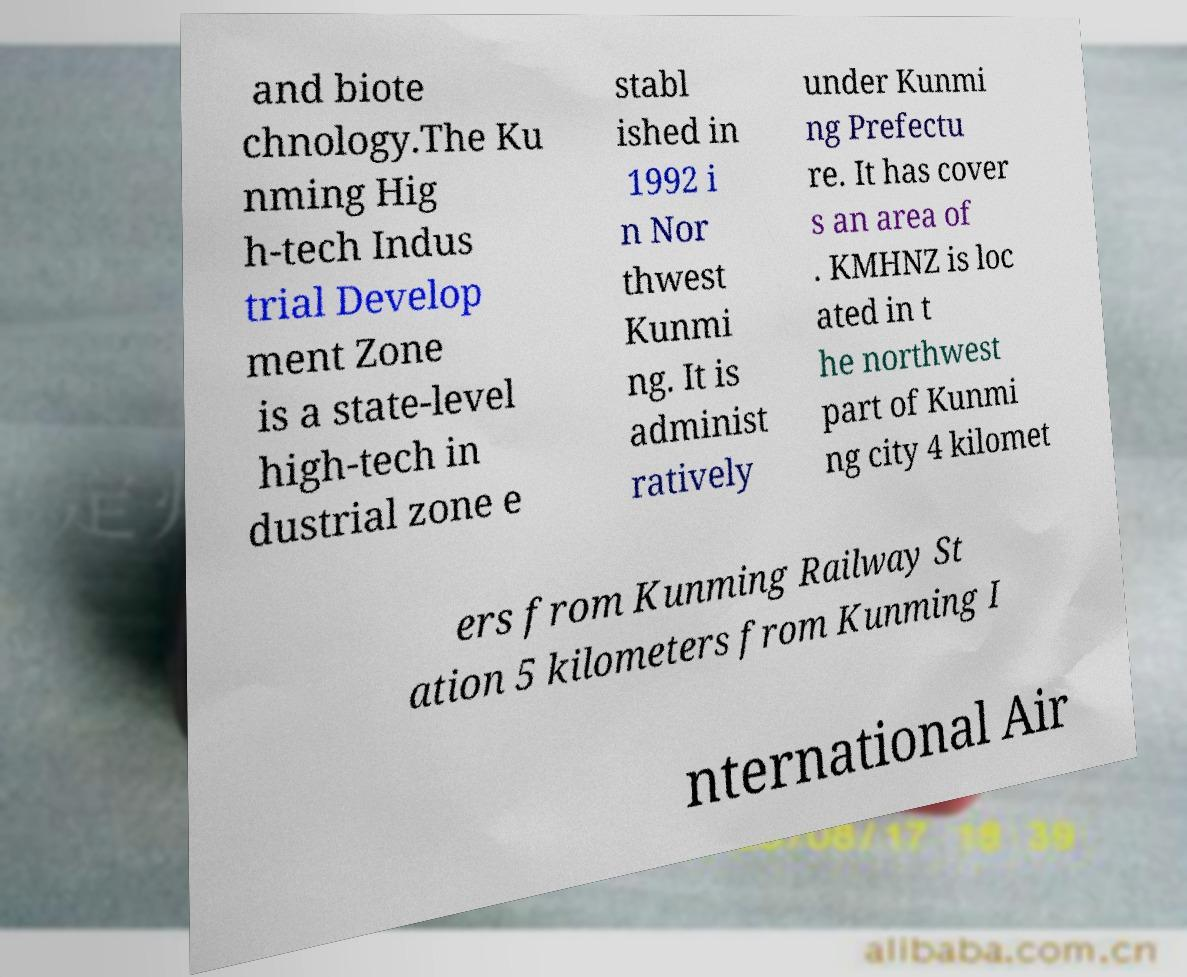Please read and relay the text visible in this image. What does it say? and biote chnology.The Ku nming Hig h-tech Indus trial Develop ment Zone is a state-level high-tech in dustrial zone e stabl ished in 1992 i n Nor thwest Kunmi ng. It is administ ratively under Kunmi ng Prefectu re. It has cover s an area of . KMHNZ is loc ated in t he northwest part of Kunmi ng city 4 kilomet ers from Kunming Railway St ation 5 kilometers from Kunming I nternational Air 